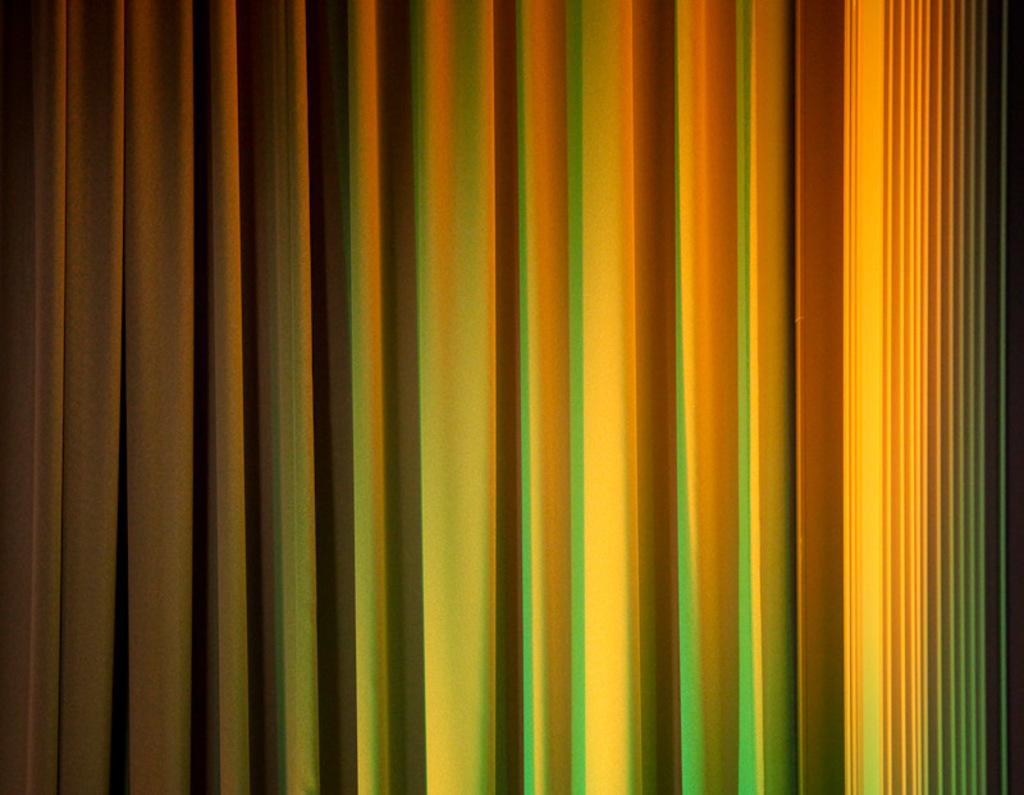Describe this image in one or two sentences. In the image we can see this is a curtain, green and yellow in color. 